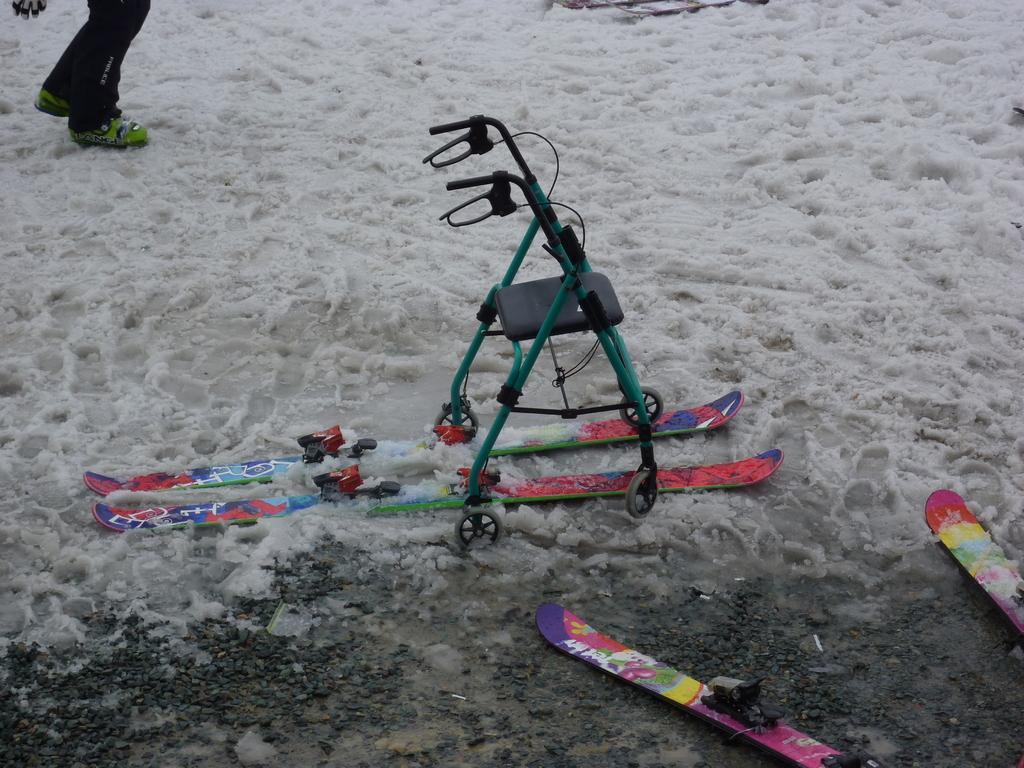How would you summarize this image in a sentence or two? In the center of the image we can see a walking aid with the seat and handles are placed in the snow, we can also see some skies placed on the ground. At the top of the image we can see a person standing on snow. 